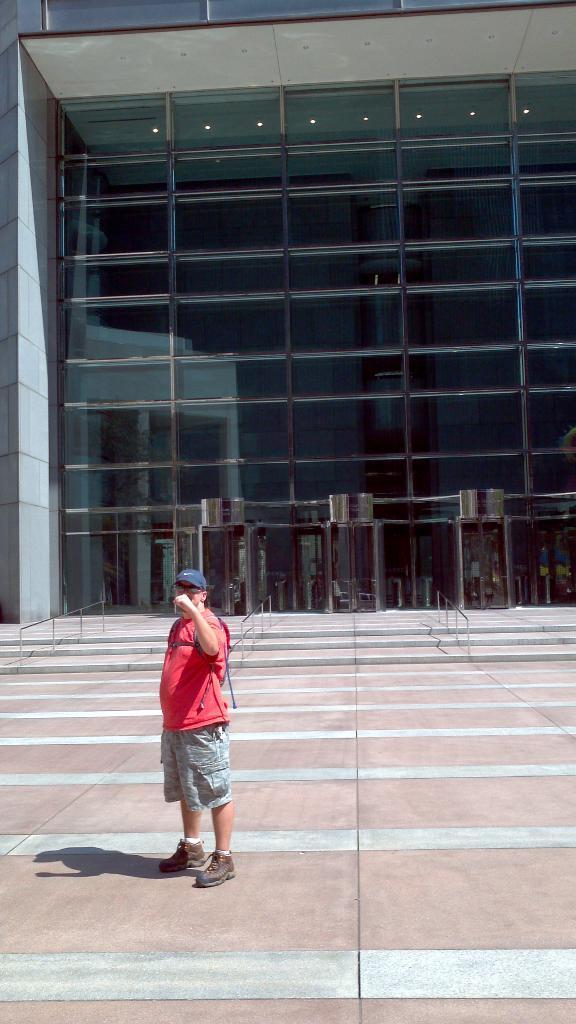In one or two sentences, can you explain what this image depicts? In this picture there is a man standing and wore cap and goggles. In the background of the image we can see railings, steps, building and lights. 